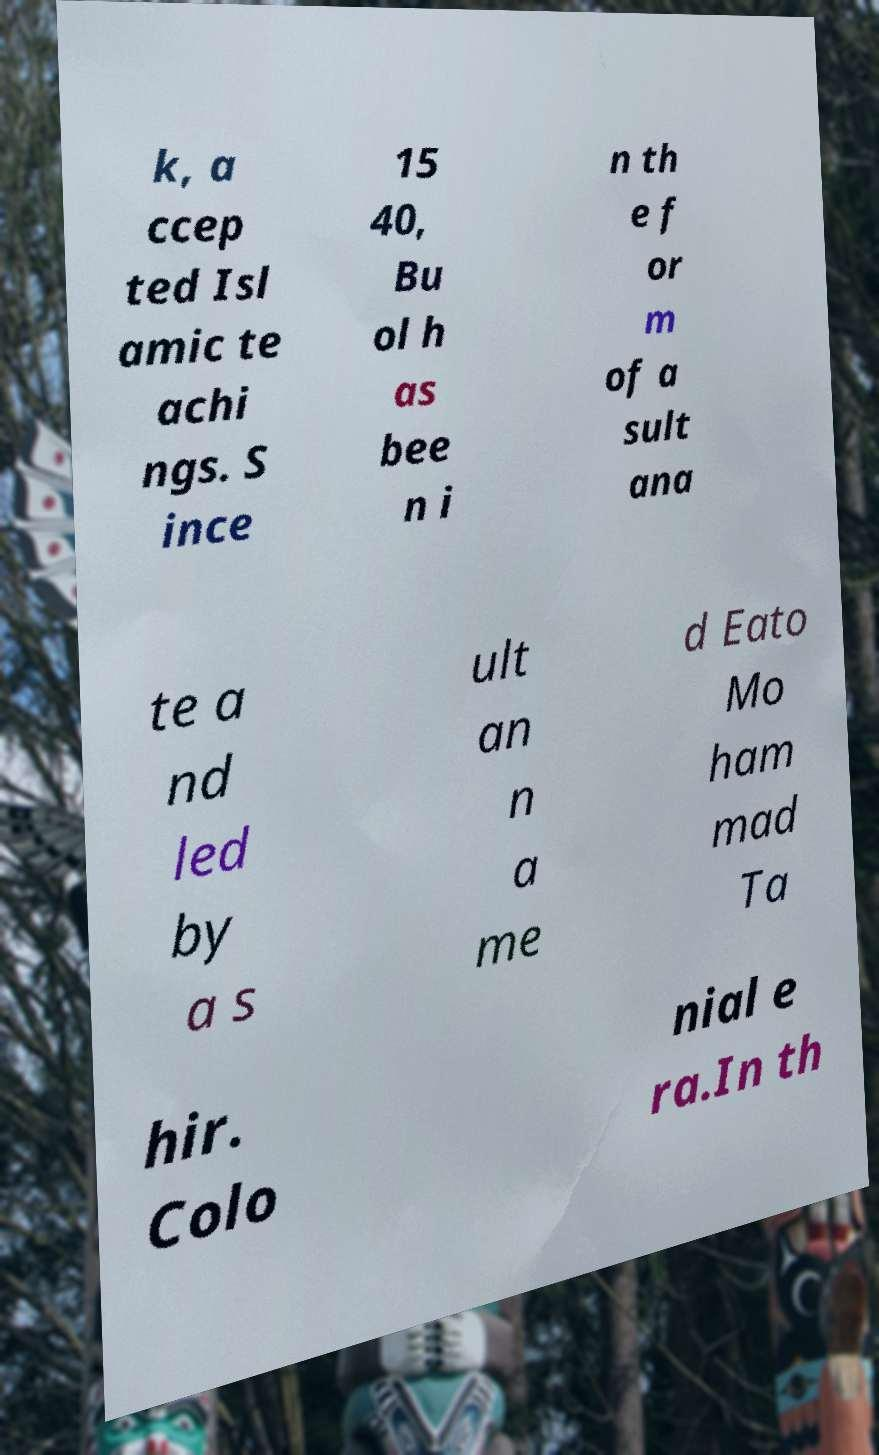Could you assist in decoding the text presented in this image and type it out clearly? k, a ccep ted Isl amic te achi ngs. S ince 15 40, Bu ol h as bee n i n th e f or m of a sult ana te a nd led by a s ult an n a me d Eato Mo ham mad Ta hir. Colo nial e ra.In th 